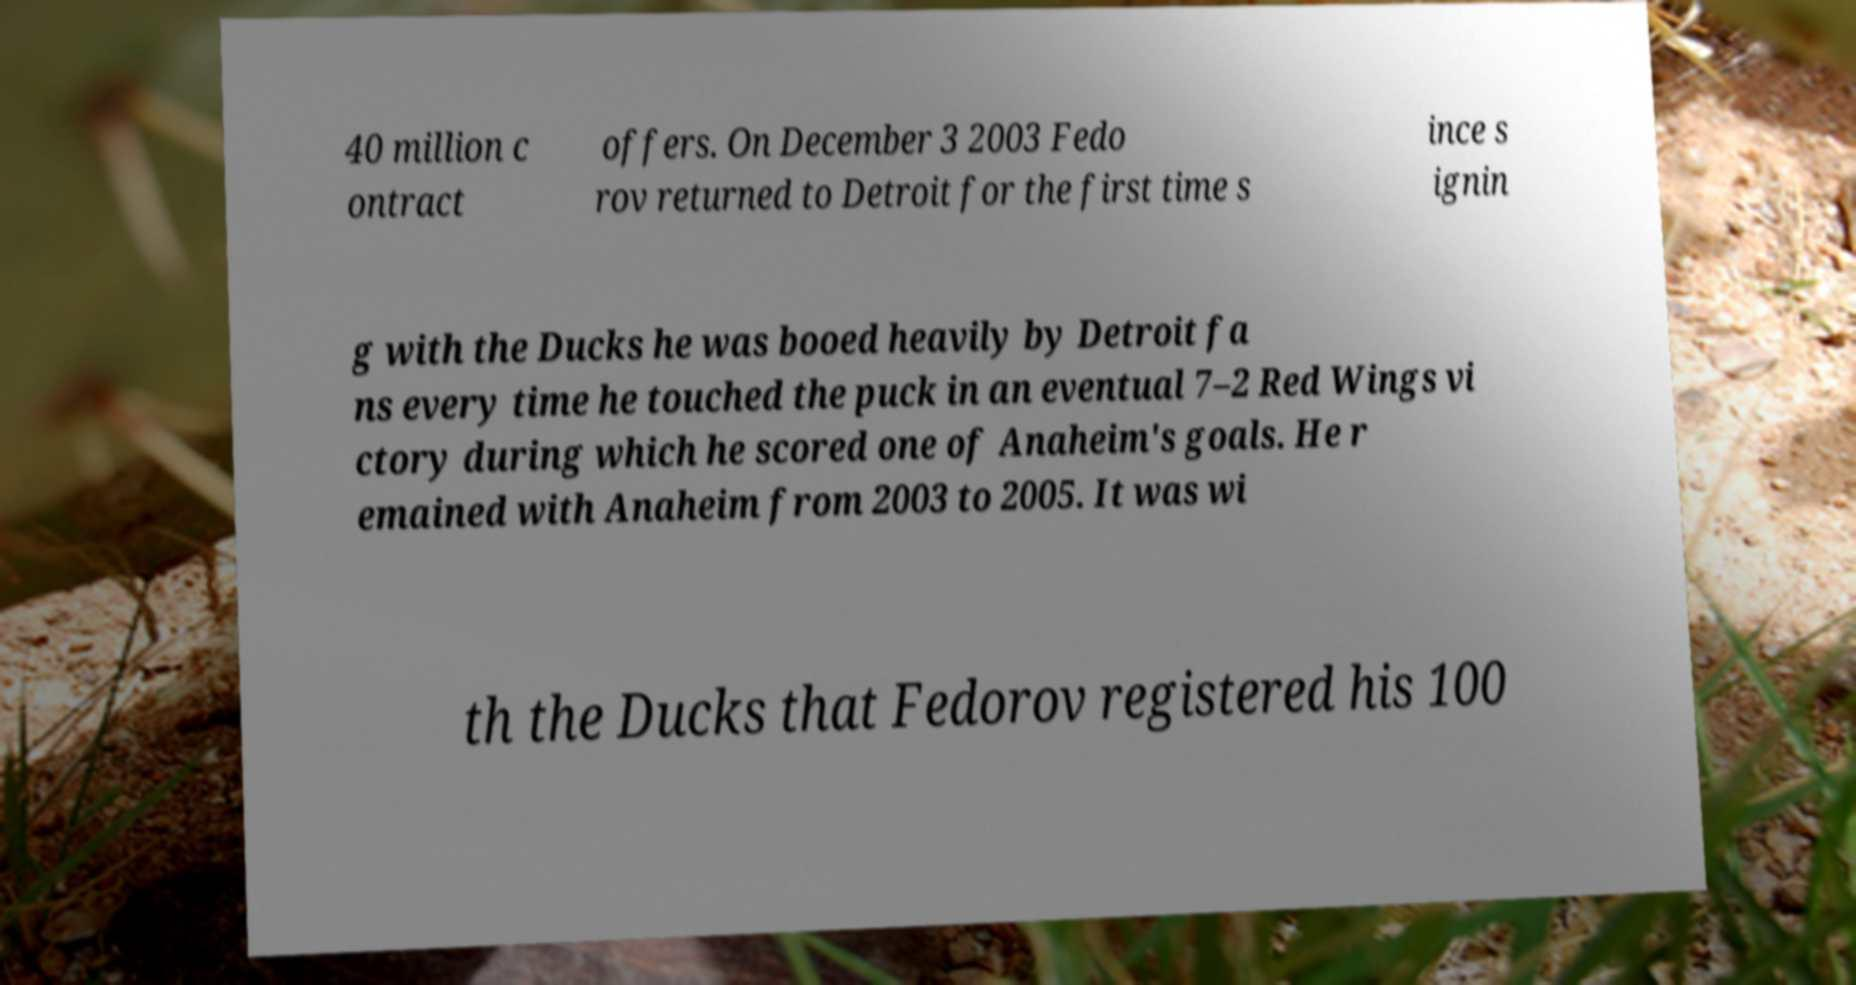There's text embedded in this image that I need extracted. Can you transcribe it verbatim? 40 million c ontract offers. On December 3 2003 Fedo rov returned to Detroit for the first time s ince s ignin g with the Ducks he was booed heavily by Detroit fa ns every time he touched the puck in an eventual 7–2 Red Wings vi ctory during which he scored one of Anaheim's goals. He r emained with Anaheim from 2003 to 2005. It was wi th the Ducks that Fedorov registered his 100 